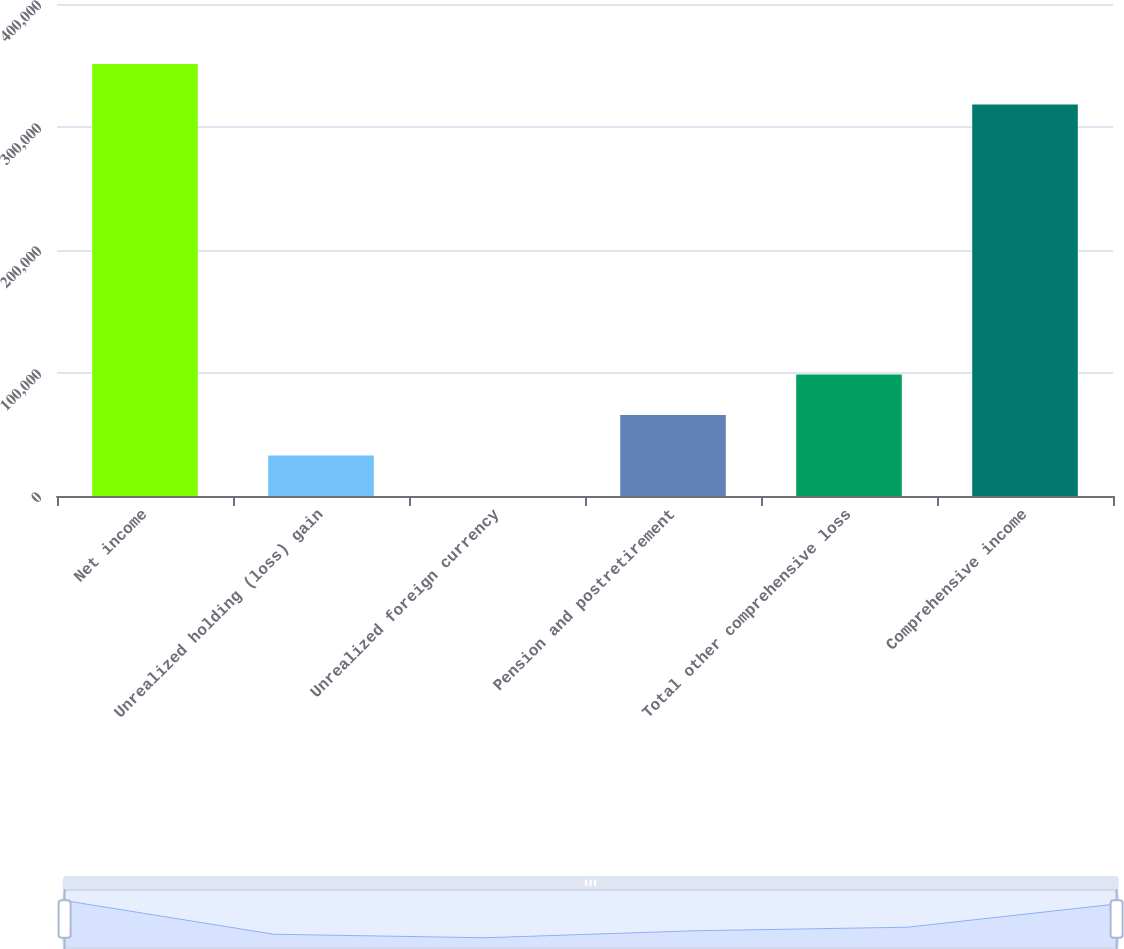<chart> <loc_0><loc_0><loc_500><loc_500><bar_chart><fcel>Net income<fcel>Unrealized holding (loss) gain<fcel>Unrealized foreign currency<fcel>Pension and postretirement<fcel>Total other comprehensive loss<fcel>Comprehensive income<nl><fcel>351182<fcel>32927.7<fcel>15<fcel>65840.4<fcel>98753.1<fcel>318269<nl></chart> 